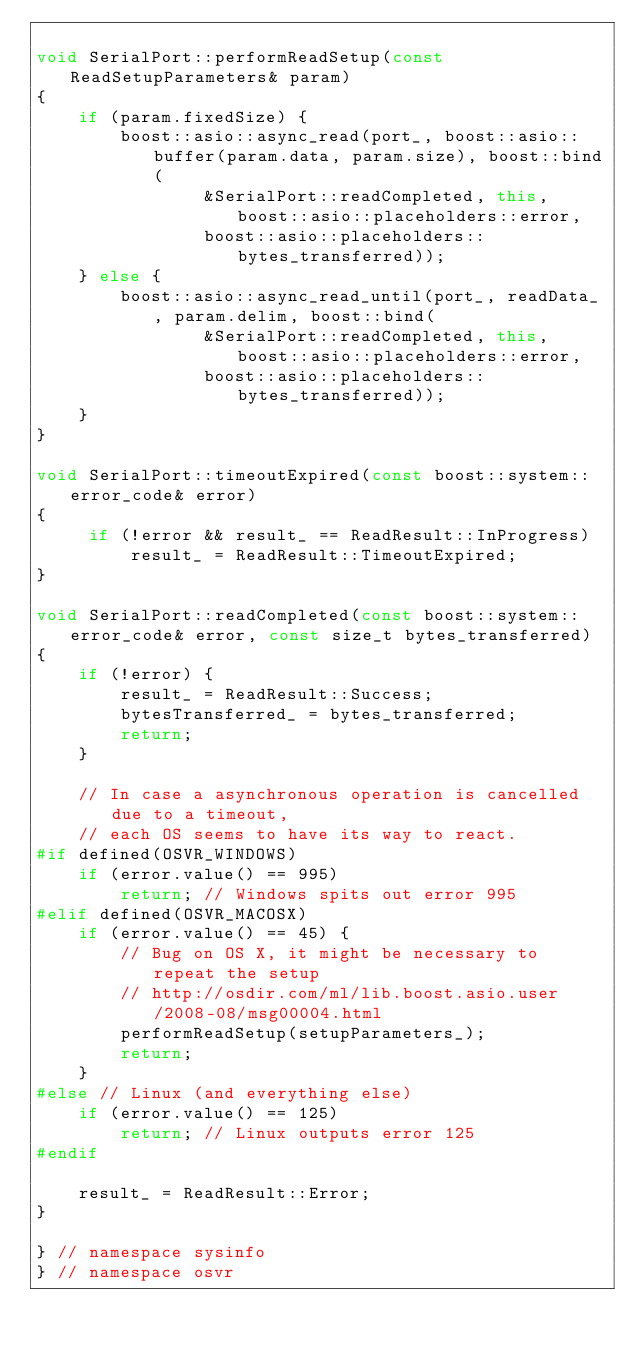<code> <loc_0><loc_0><loc_500><loc_500><_C++_>
void SerialPort::performReadSetup(const ReadSetupParameters& param)
{
    if (param.fixedSize) {
        boost::asio::async_read(port_, boost::asio::buffer(param.data, param.size), boost::bind(
                &SerialPort::readCompleted, this, boost::asio::placeholders::error, 
                boost::asio::placeholders::bytes_transferred));
    } else {
        boost::asio::async_read_until(port_, readData_, param.delim, boost::bind(
                &SerialPort::readCompleted, this, boost::asio::placeholders::error, 
                boost::asio::placeholders::bytes_transferred));
    }
}

void SerialPort::timeoutExpired(const boost::system::error_code& error)
{
     if (!error && result_ == ReadResult::InProgress)
         result_ = ReadResult::TimeoutExpired;
}

void SerialPort::readCompleted(const boost::system::error_code& error, const size_t bytes_transferred)
{
    if (!error) {
        result_ = ReadResult::Success;
        bytesTransferred_ = bytes_transferred;
        return;
    }

    // In case a asynchronous operation is cancelled due to a timeout,
    // each OS seems to have its way to react.
#if defined(OSVR_WINDOWS)
    if (error.value() == 995)
        return; // Windows spits out error 995
#elif defined(OSVR_MACOSX)
    if (error.value() == 45) {
        // Bug on OS X, it might be necessary to repeat the setup
        // http://osdir.com/ml/lib.boost.asio.user/2008-08/msg00004.html
        performReadSetup(setupParameters_);
        return;
    }
#else // Linux (and everything else)
    if (error.value() == 125)
        return; // Linux outputs error 125
#endif

    result_ = ReadResult::Error;
}

} // namespace sysinfo
} // namespace osvr

</code> 